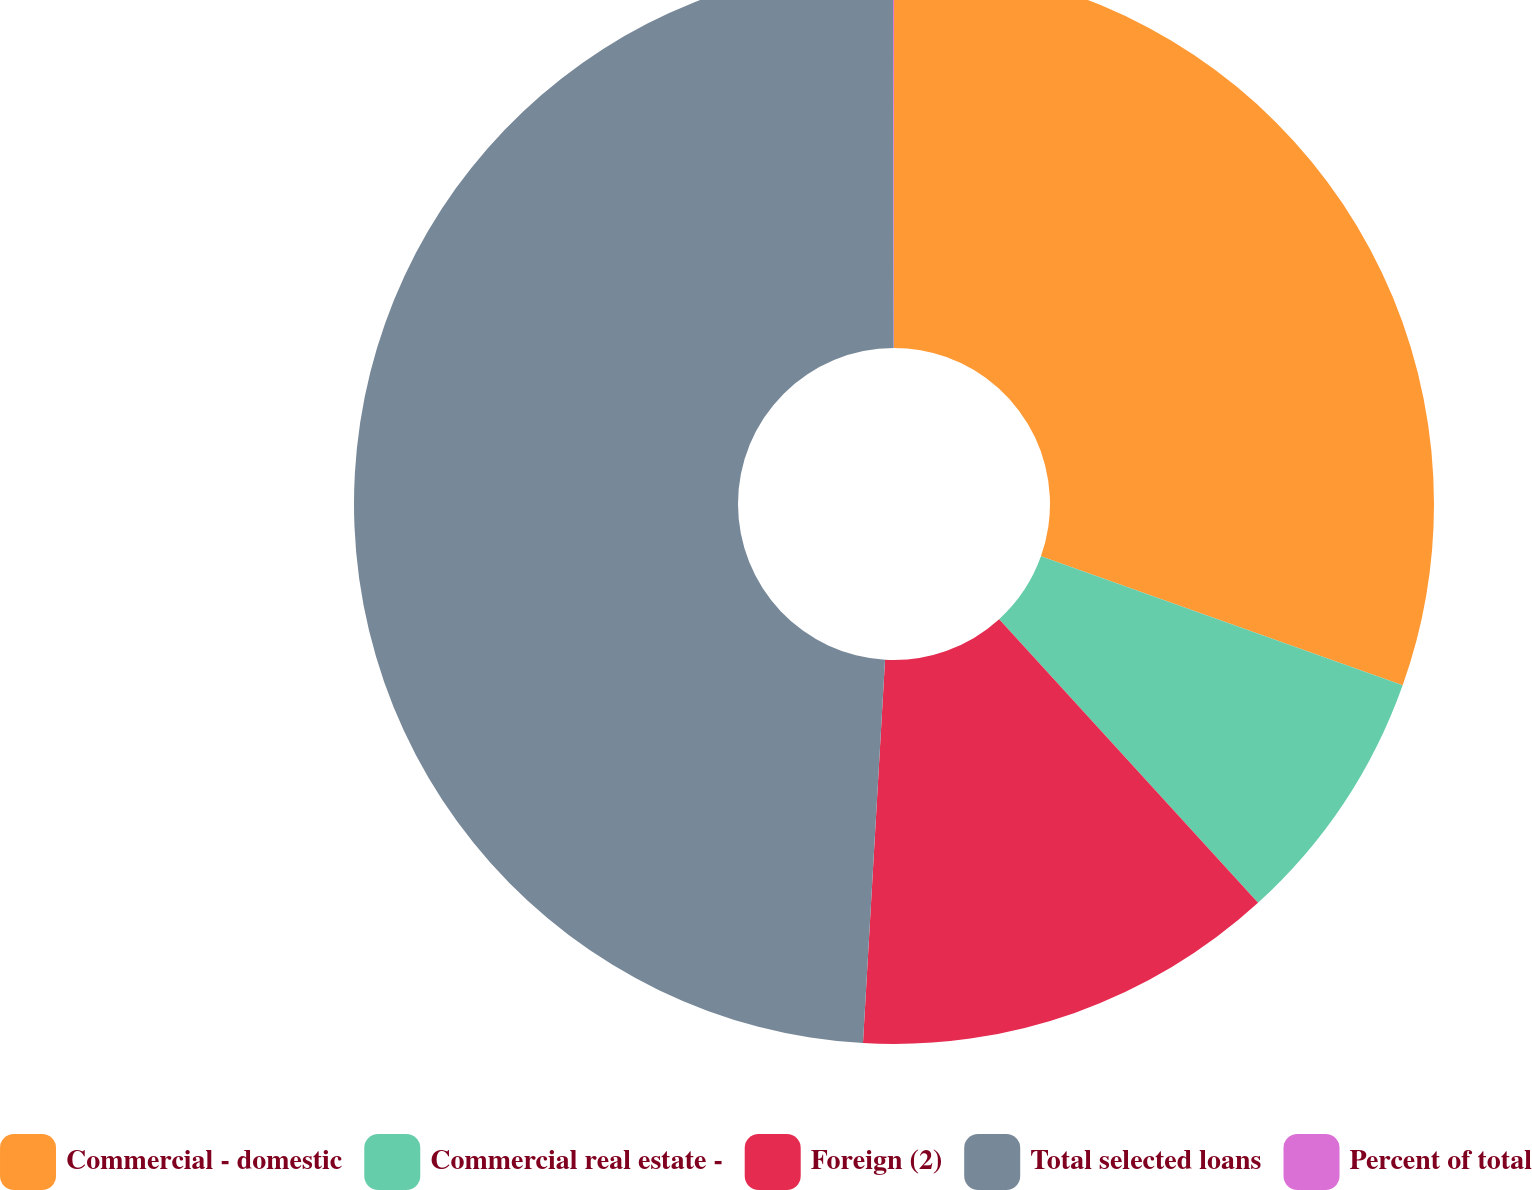Convert chart to OTSL. <chart><loc_0><loc_0><loc_500><loc_500><pie_chart><fcel>Commercial - domestic<fcel>Commercial real estate -<fcel>Foreign (2)<fcel>Total selected loans<fcel>Percent of total<nl><fcel>30.45%<fcel>7.78%<fcel>12.69%<fcel>49.06%<fcel>0.03%<nl></chart> 